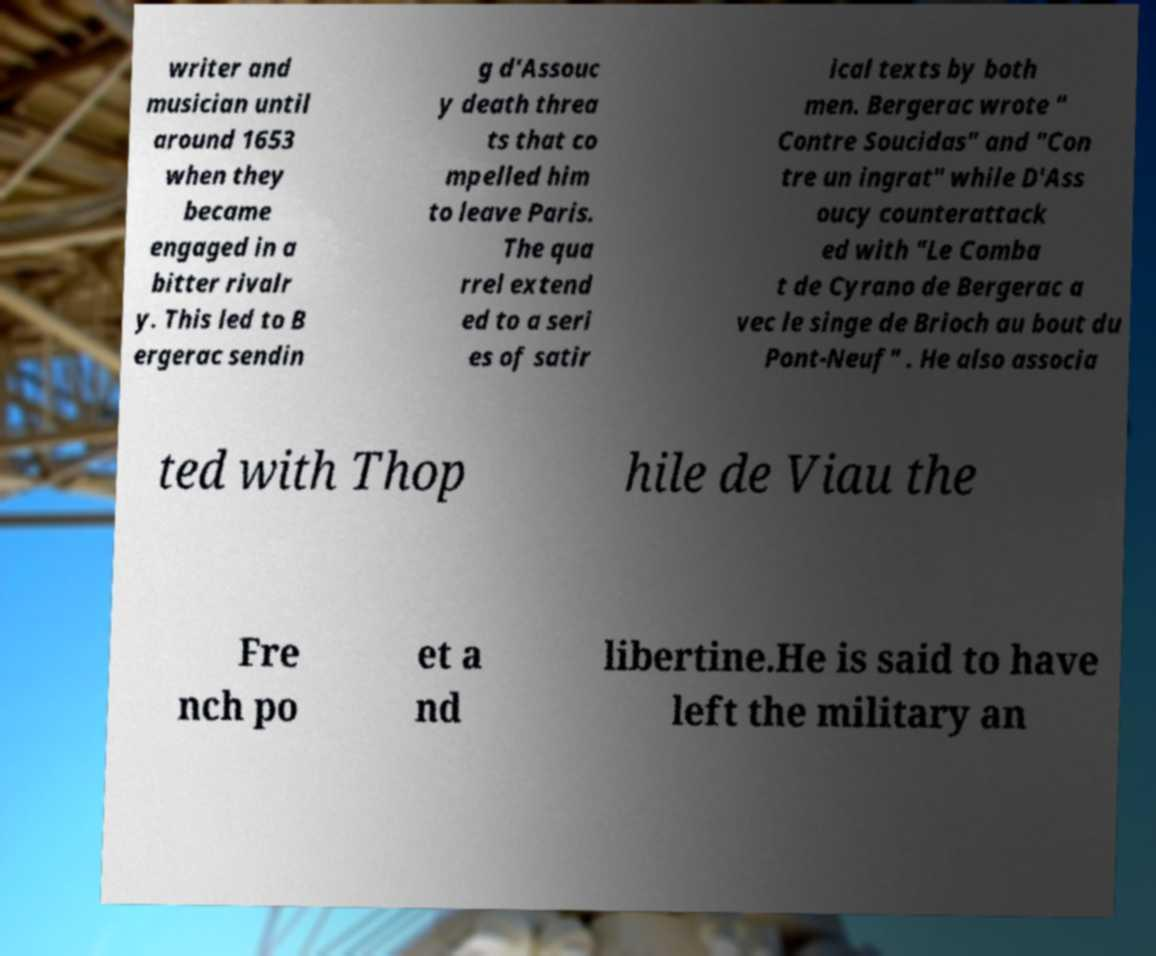I need the written content from this picture converted into text. Can you do that? writer and musician until around 1653 when they became engaged in a bitter rivalr y. This led to B ergerac sendin g d'Assouc y death threa ts that co mpelled him to leave Paris. The qua rrel extend ed to a seri es of satir ical texts by both men. Bergerac wrote " Contre Soucidas" and "Con tre un ingrat" while D'Ass oucy counterattack ed with "Le Comba t de Cyrano de Bergerac a vec le singe de Brioch au bout du Pont-Neuf" . He also associa ted with Thop hile de Viau the Fre nch po et a nd libertine.He is said to have left the military an 